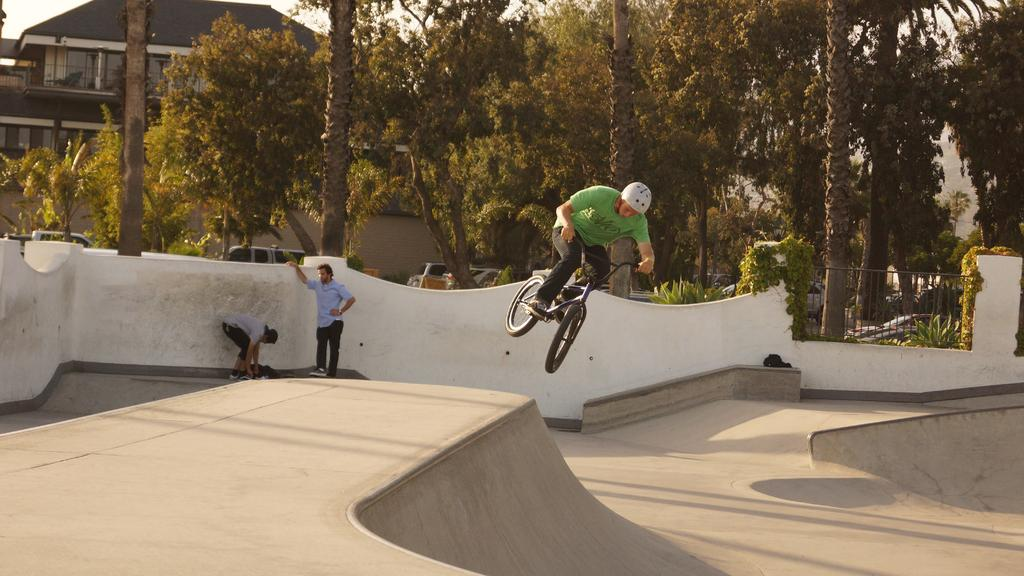How many persons can be seen in the image? There are a few persons in the image. What activity is one of the persons engaged in? One person is riding a bicycle. What type of structure is present in the image? There is a house in the image. What type of vegetation is visible in the image? There are plants and trees in the image. What type of objects are present in the image? There are vehicles and grills in the image. What part of the natural environment is visible in the image? The sky is visible in the image. What type of bubble can be seen floating in the image? There is no bubble present in the image. What type of music is being played in the image? There is no indication of music being played in the image. 